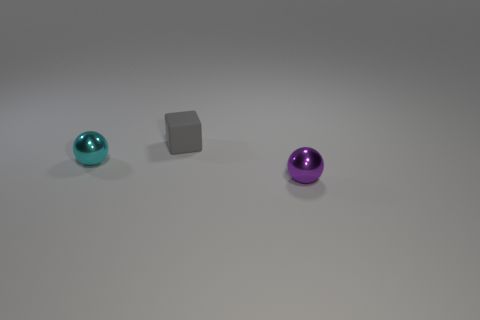Can you describe the objects in the picture? Certainly! There are three objects in the image: a cyan-colored ball with a reflective surface, a matte gray cube, and a purple ball that also has a reflective surface. All objects are placed on what appears to be a flat, neutral-toned surface under soft lighting. 